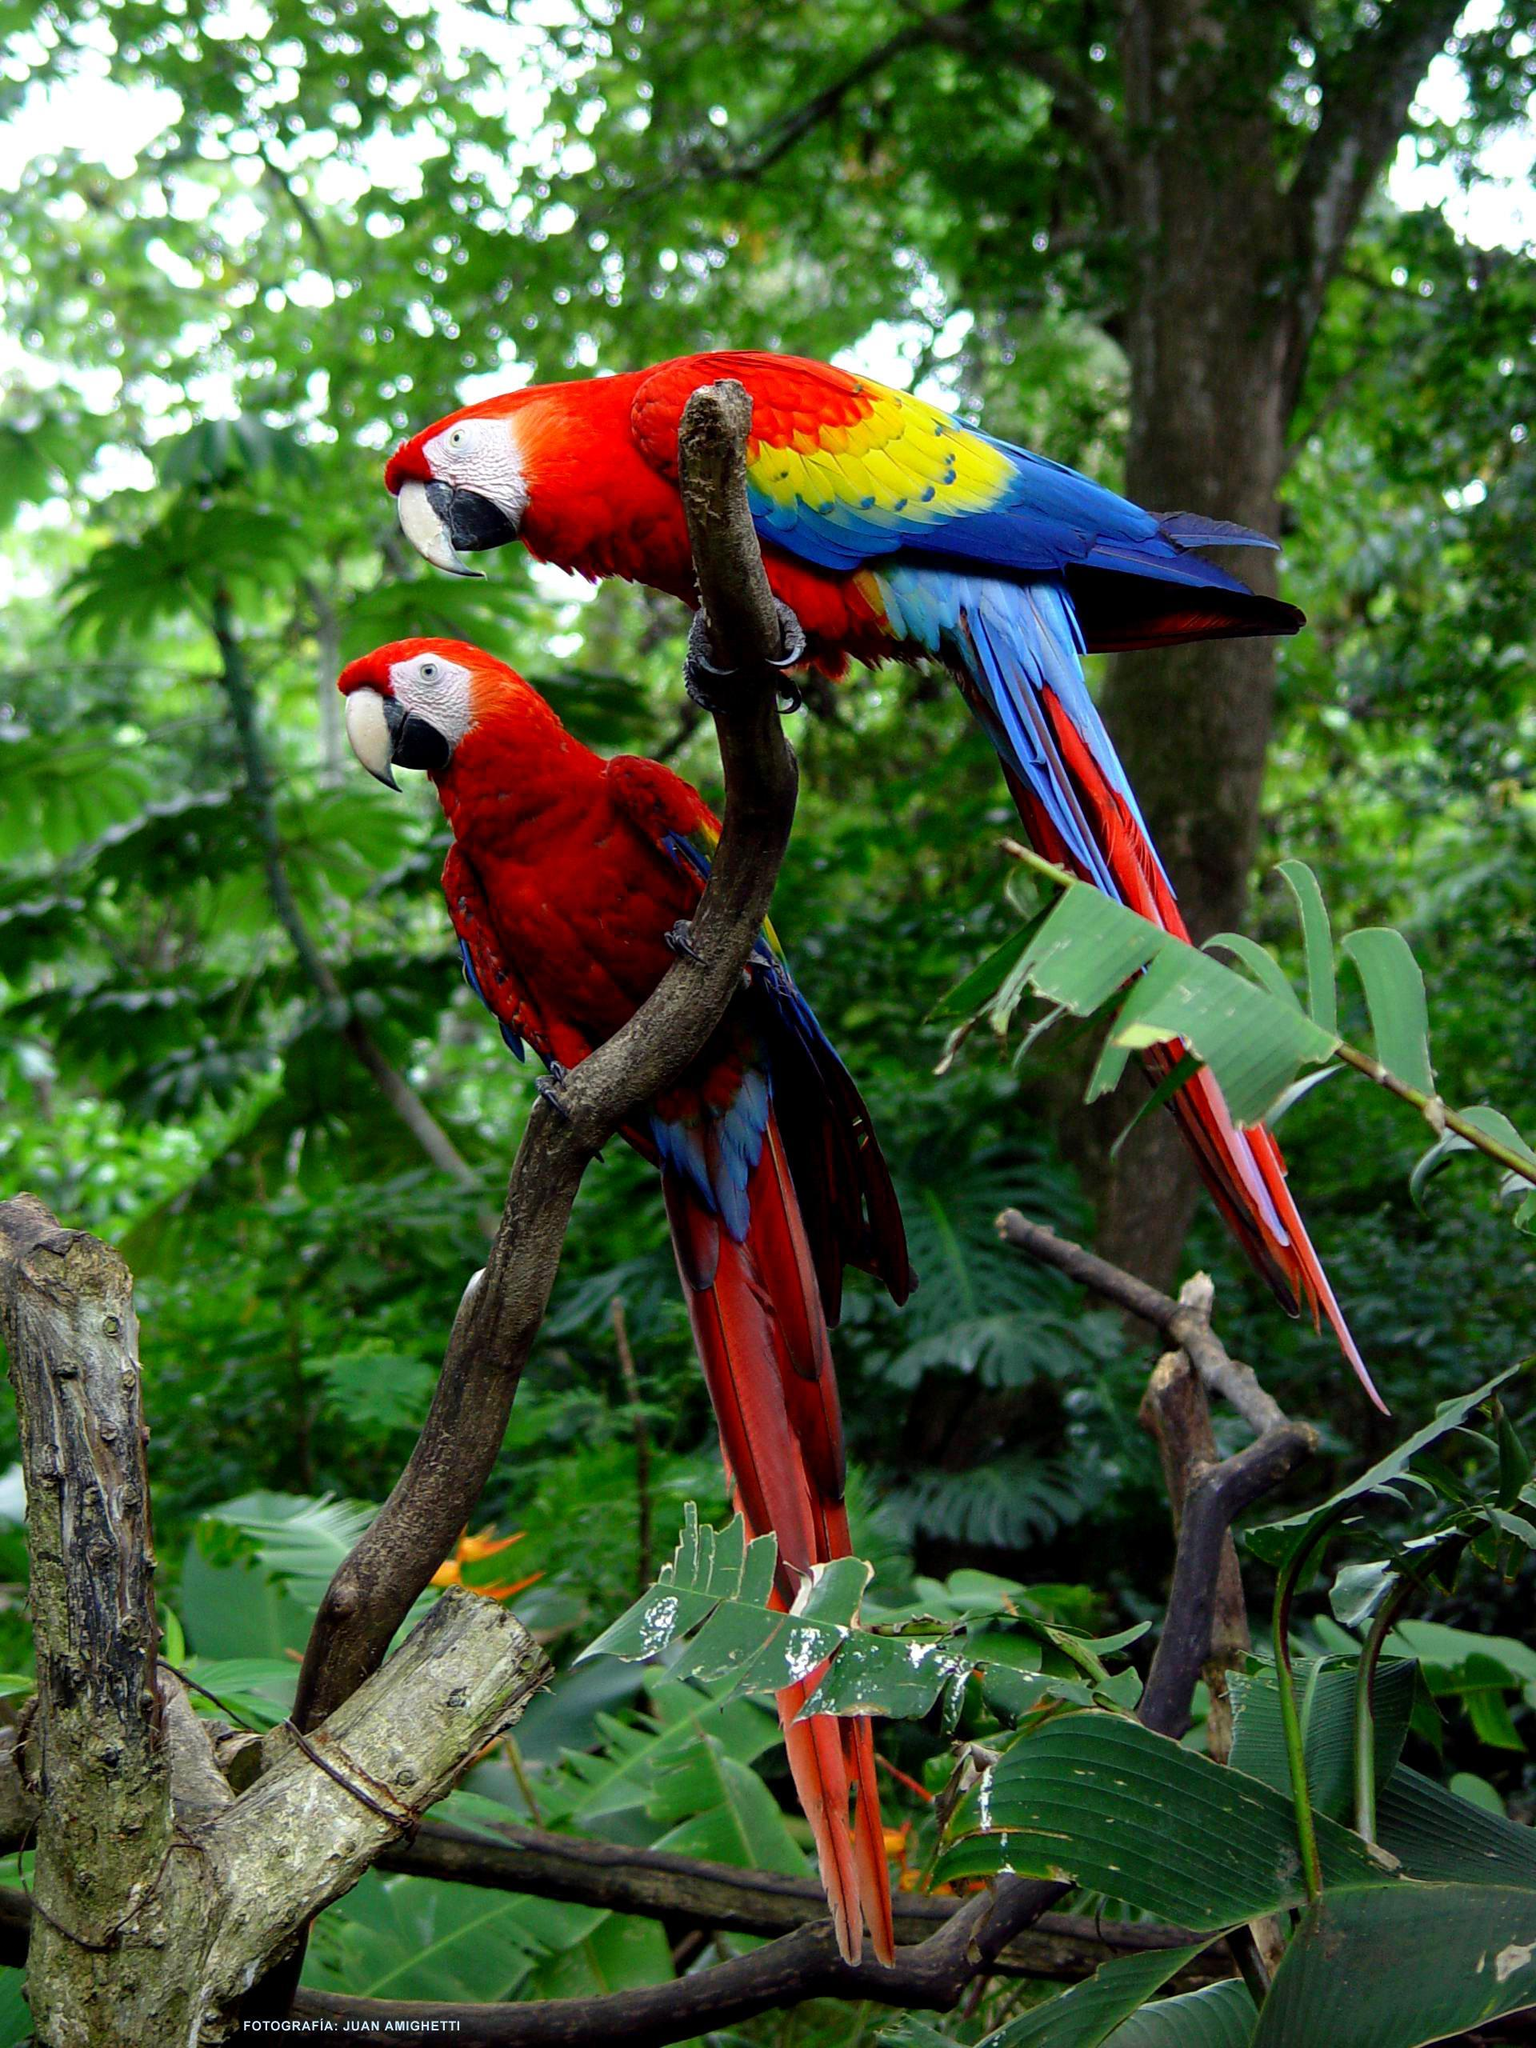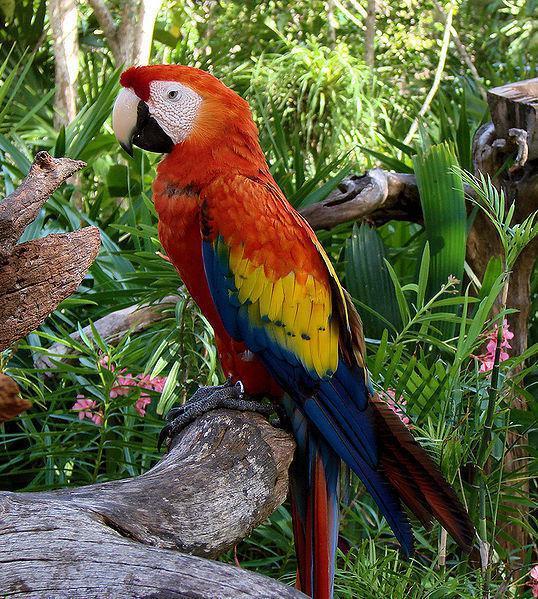The first image is the image on the left, the second image is the image on the right. For the images shown, is this caption "There is at least one yellow breasted bird in the image on the left." true? Answer yes or no. No. 